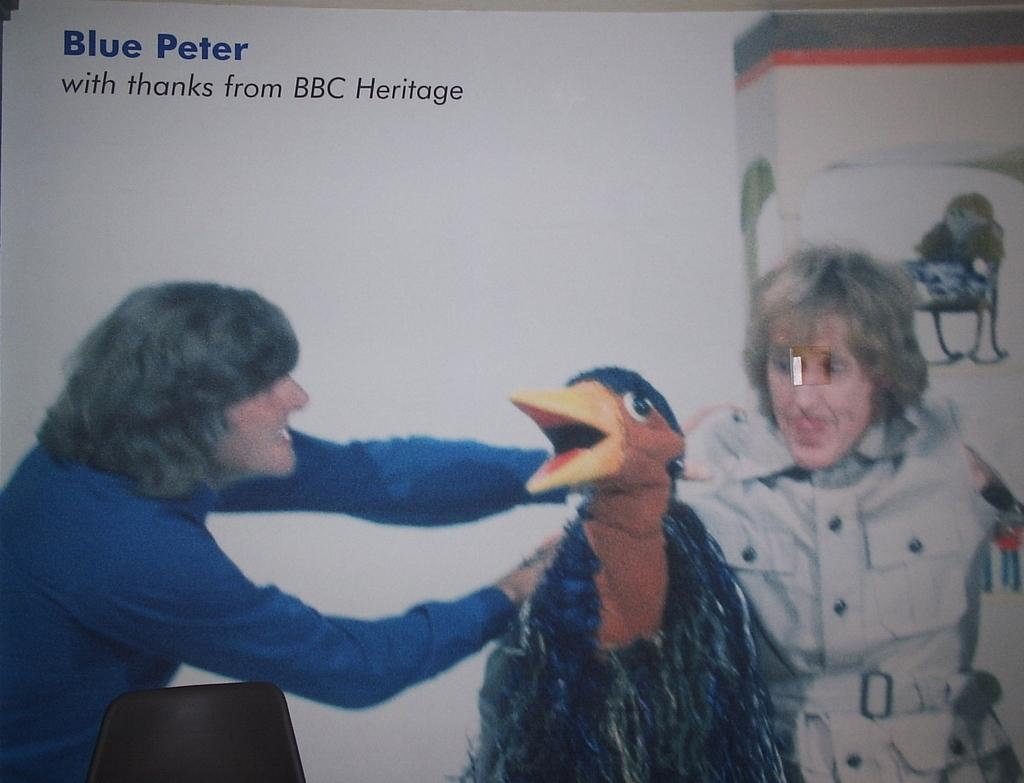What is present in the image? There is a poster in the image. What can be seen on the poster? There are two persons depicted in the poster. How many wheels are visible on the poster? There are no wheels visible on the poster; it features two persons. What type of service do the servants provide in the image? There are no servants present in the image, as it only features two persons. 